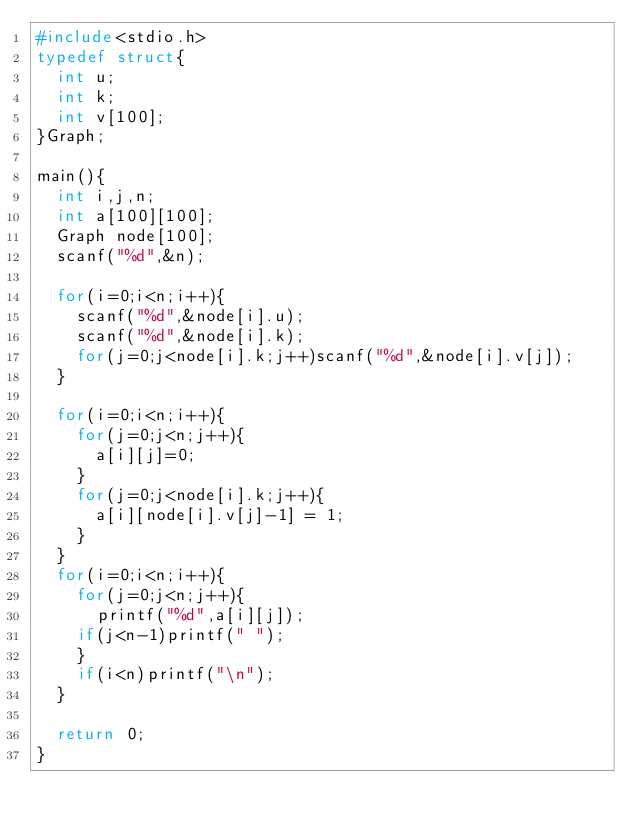Convert code to text. <code><loc_0><loc_0><loc_500><loc_500><_C_>#include<stdio.h>
typedef struct{
  int u;
  int k;
  int v[100];
}Graph;

main(){
  int i,j,n;
  int a[100][100];
  Graph node[100];
  scanf("%d",&n);

  for(i=0;i<n;i++){
    scanf("%d",&node[i].u);
    scanf("%d",&node[i].k);
    for(j=0;j<node[i].k;j++)scanf("%d",&node[i].v[j]);
  }

  for(i=0;i<n;i++){
    for(j=0;j<n;j++){
      a[i][j]=0;
    }
    for(j=0;j<node[i].k;j++){
      a[i][node[i].v[j]-1] = 1;
    }
  }
  for(i=0;i<n;i++){
    for(j=0;j<n;j++){
      printf("%d",a[i][j]);
    if(j<n-1)printf(" ");
    }
    if(i<n)printf("\n");
  }

  return 0;
}</code> 